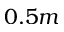<formula> <loc_0><loc_0><loc_500><loc_500>0 . 5 m</formula> 